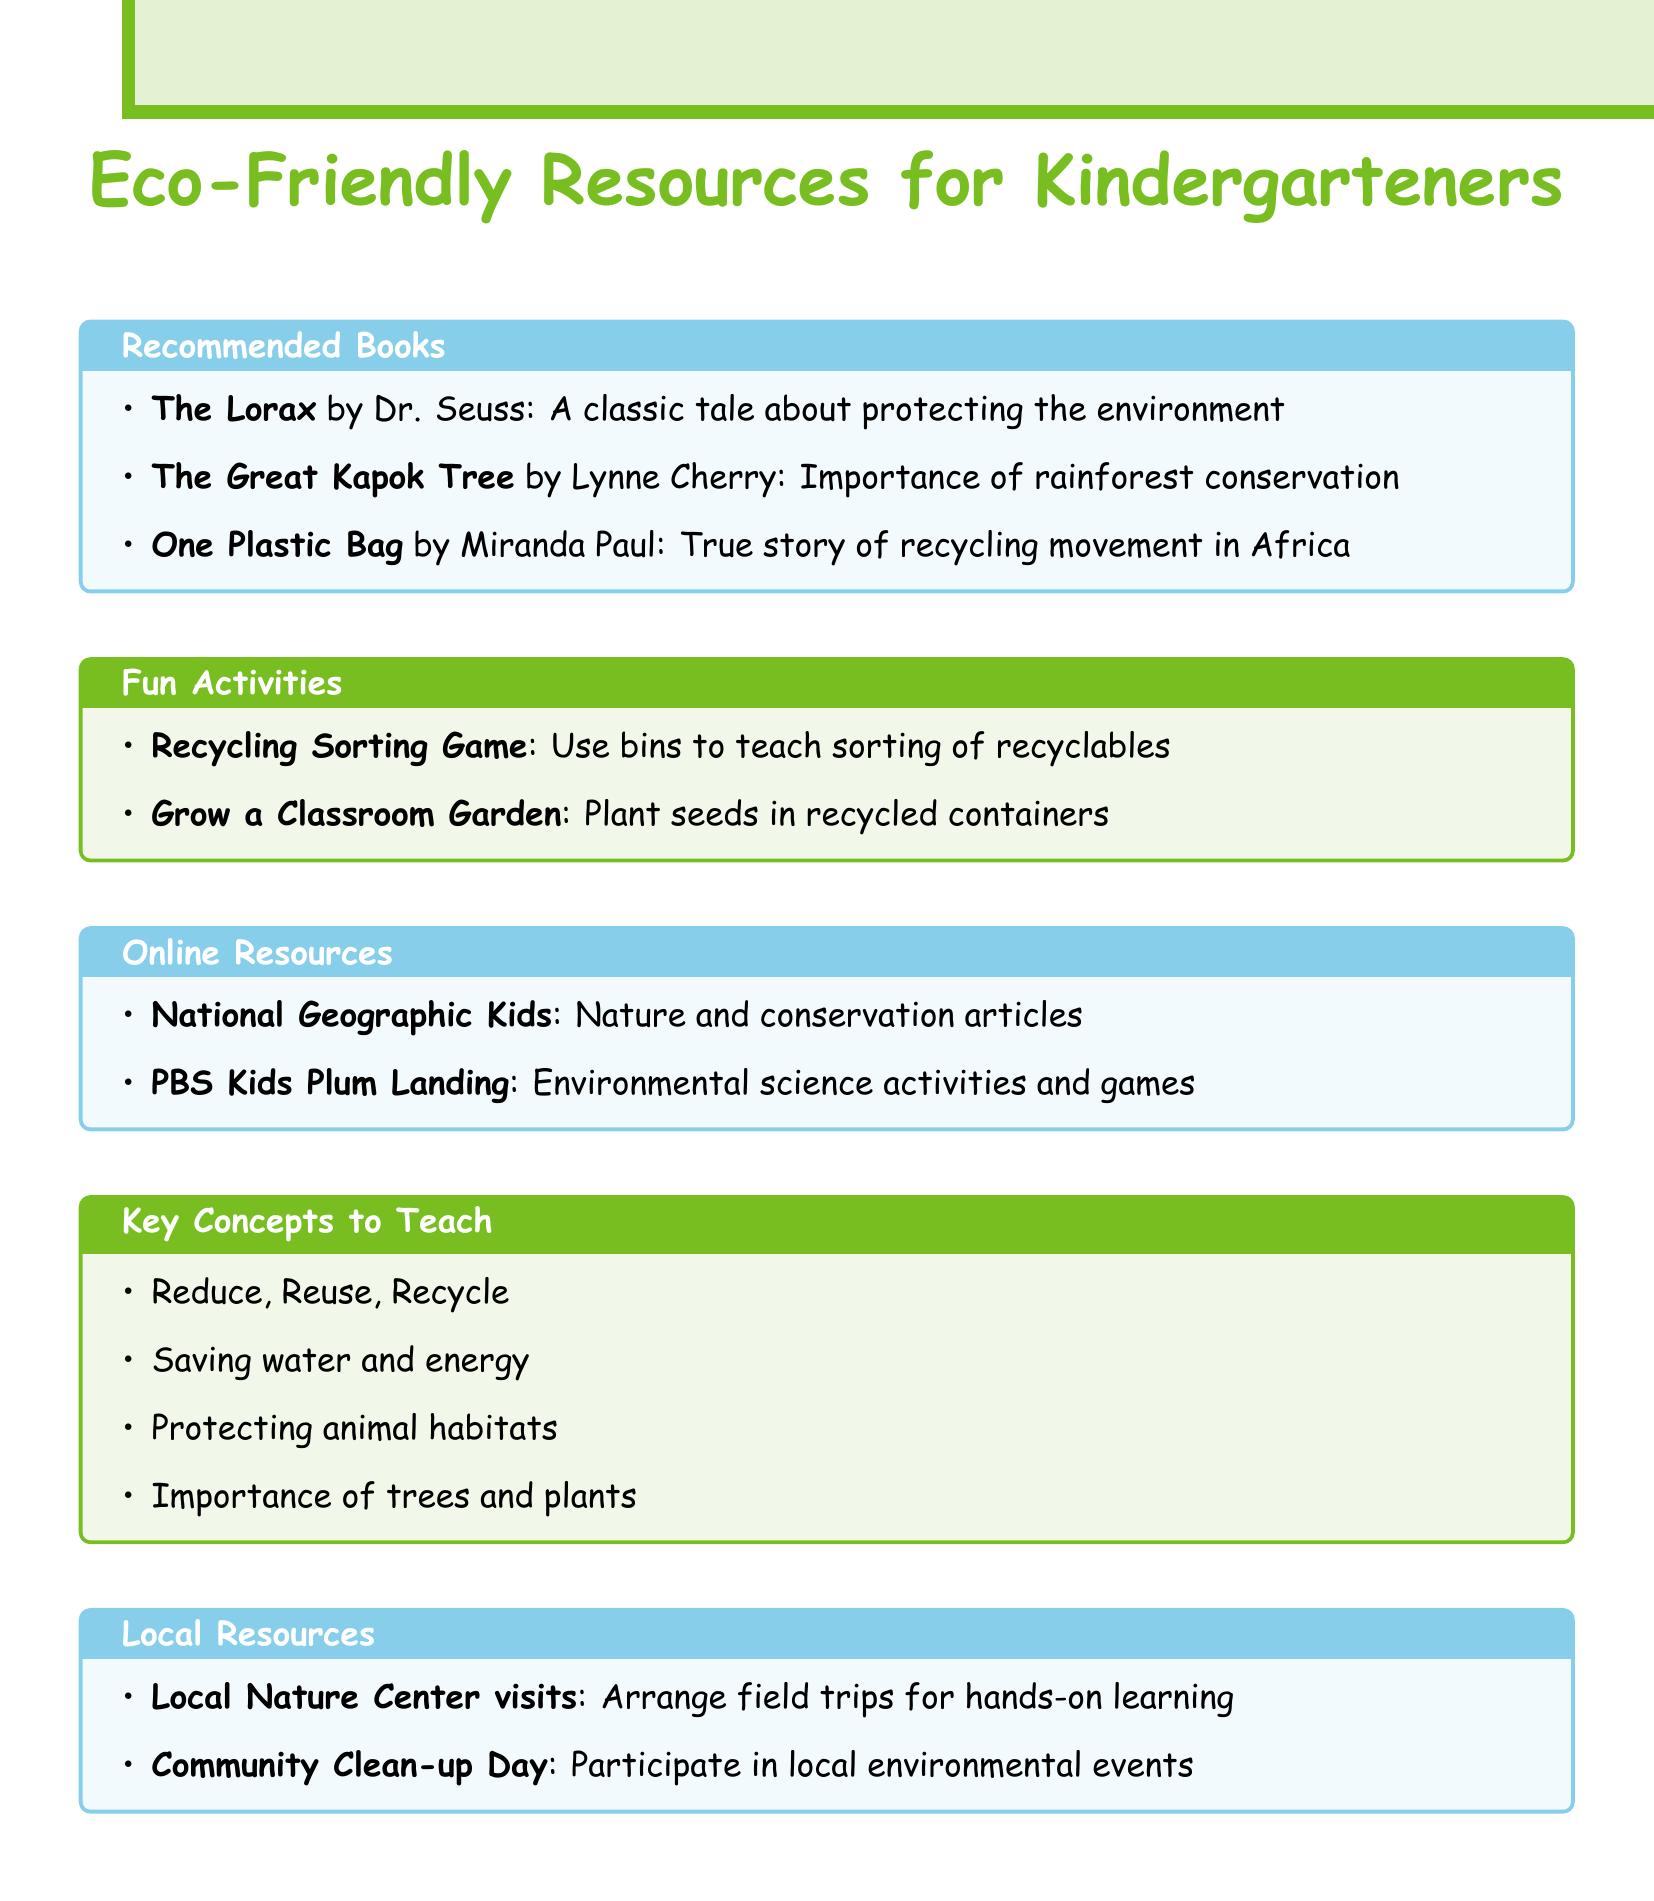What is the title of the book by Dr. Seuss? The title of the book written by Dr. Seuss is mentioned in the "Recommended Books" section.
Answer: The Lorax How many books are listed in the document? The document provides a list of books in the "Recommended Books" section and the total number is counted.
Answer: 3 What key concept emphasizes the importance of conserving resources? The key concepts listed include phrases about conservation and environment. This phrase directly relates to the idea of resource conservation.
Answer: Reduce, Reuse, Recycle What activity teaches kids about plant life cycles? The activities section describes a specific activity that allows children to learn about plants and their growth stages.
Answer: Grow a Classroom Garden Which online resource offers articles about nature? The online resources section mentions a specific site providing articles and information regarding the natural world.
Answer: National Geographic Kids Name one local resource mentioned for hands-on learning. The local resources section lists various options for experiential learning, and one of them is specified.
Answer: Local Nature Center visits 